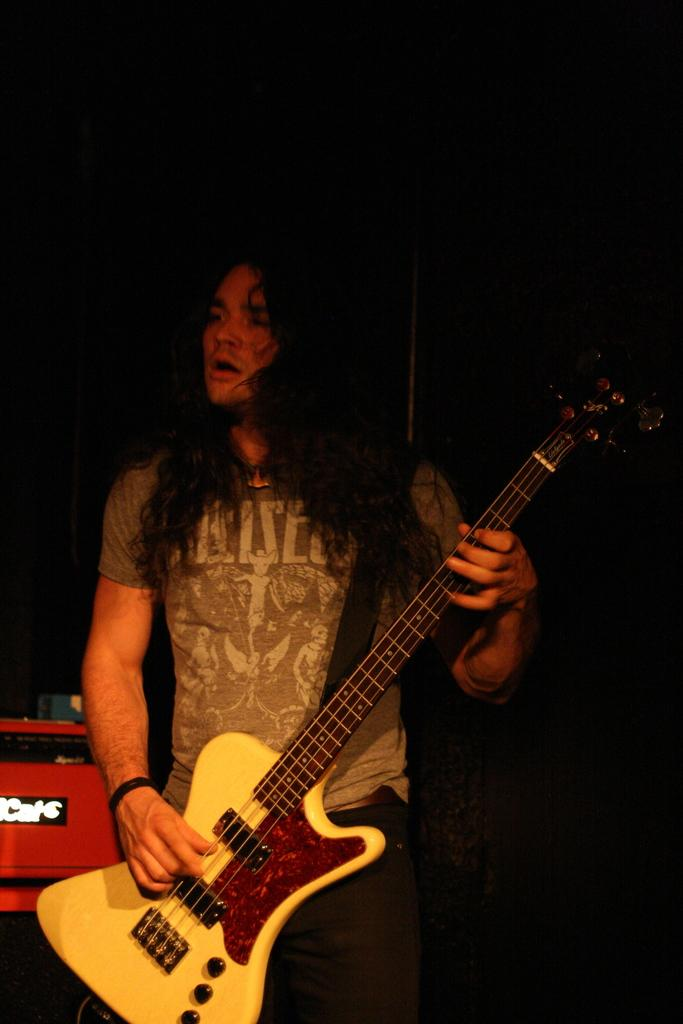What is the person in the image doing? The person is holding a guitar. What is the person wearing in the image? The person is wearing a t-shirt. What object can be seen in the image besides the person and the guitar? There is a red box in the image. What type of rice is being used to create the art in the image? There is no rice or art present in the image; it features a person holding a guitar and wearing a t-shirt, along with a red box. 